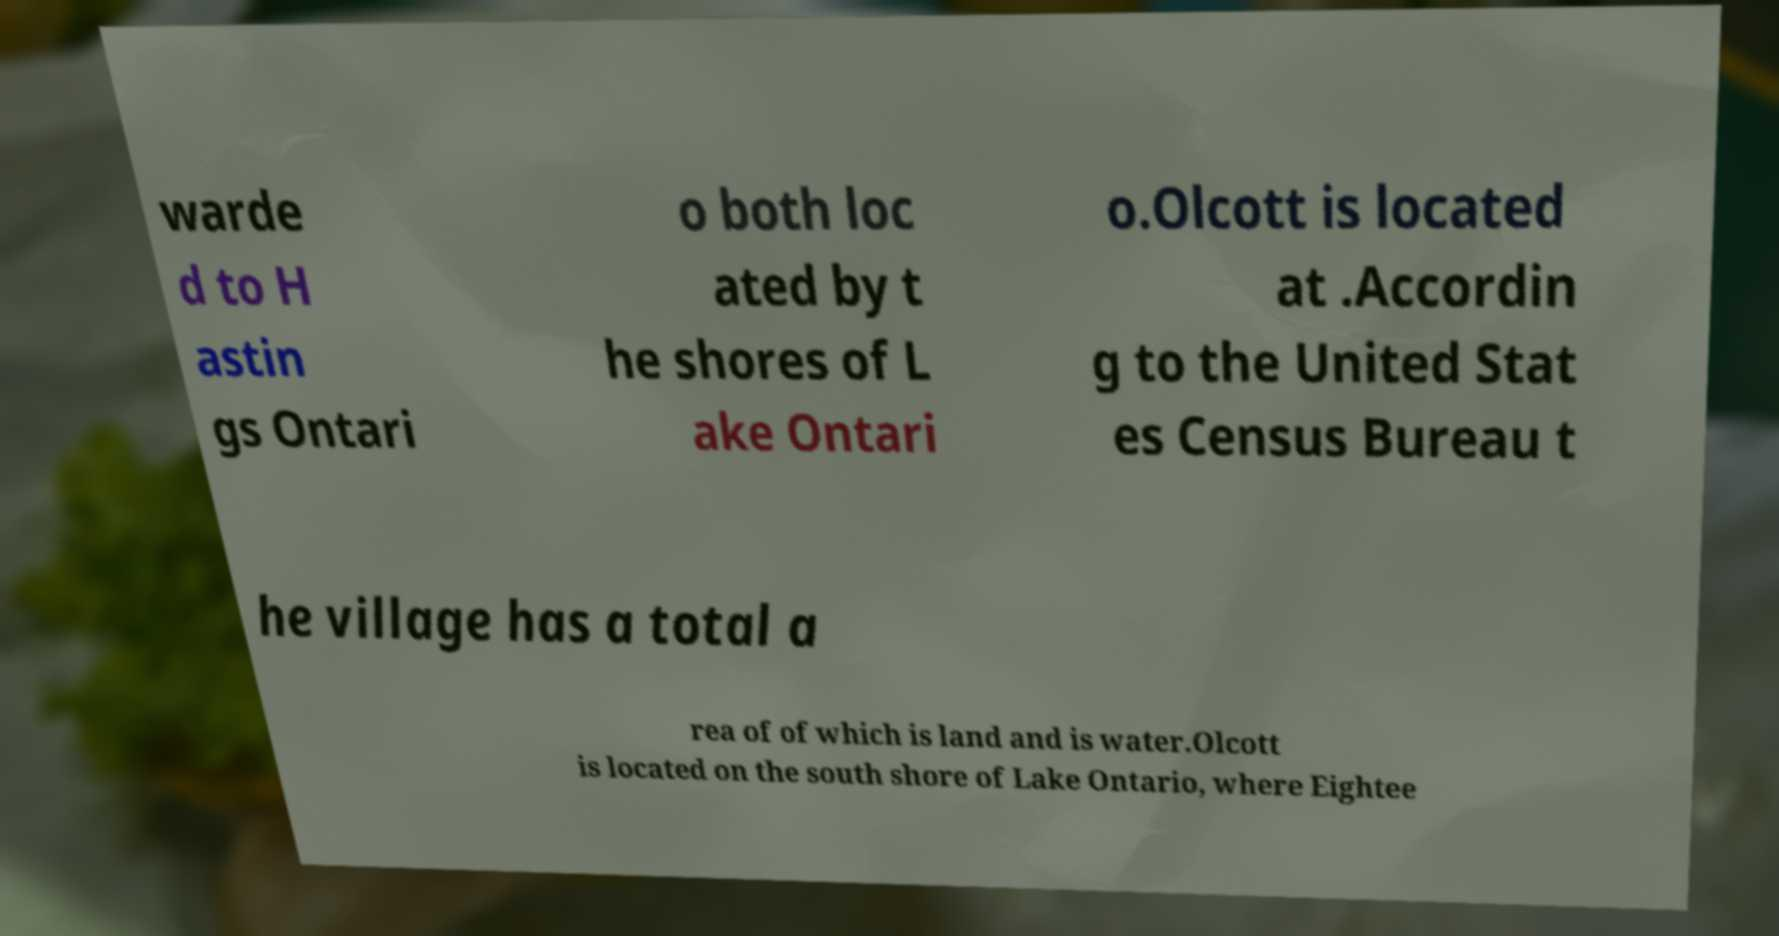Could you assist in decoding the text presented in this image and type it out clearly? warde d to H astin gs Ontari o both loc ated by t he shores of L ake Ontari o.Olcott is located at .Accordin g to the United Stat es Census Bureau t he village has a total a rea of of which is land and is water.Olcott is located on the south shore of Lake Ontario, where Eightee 